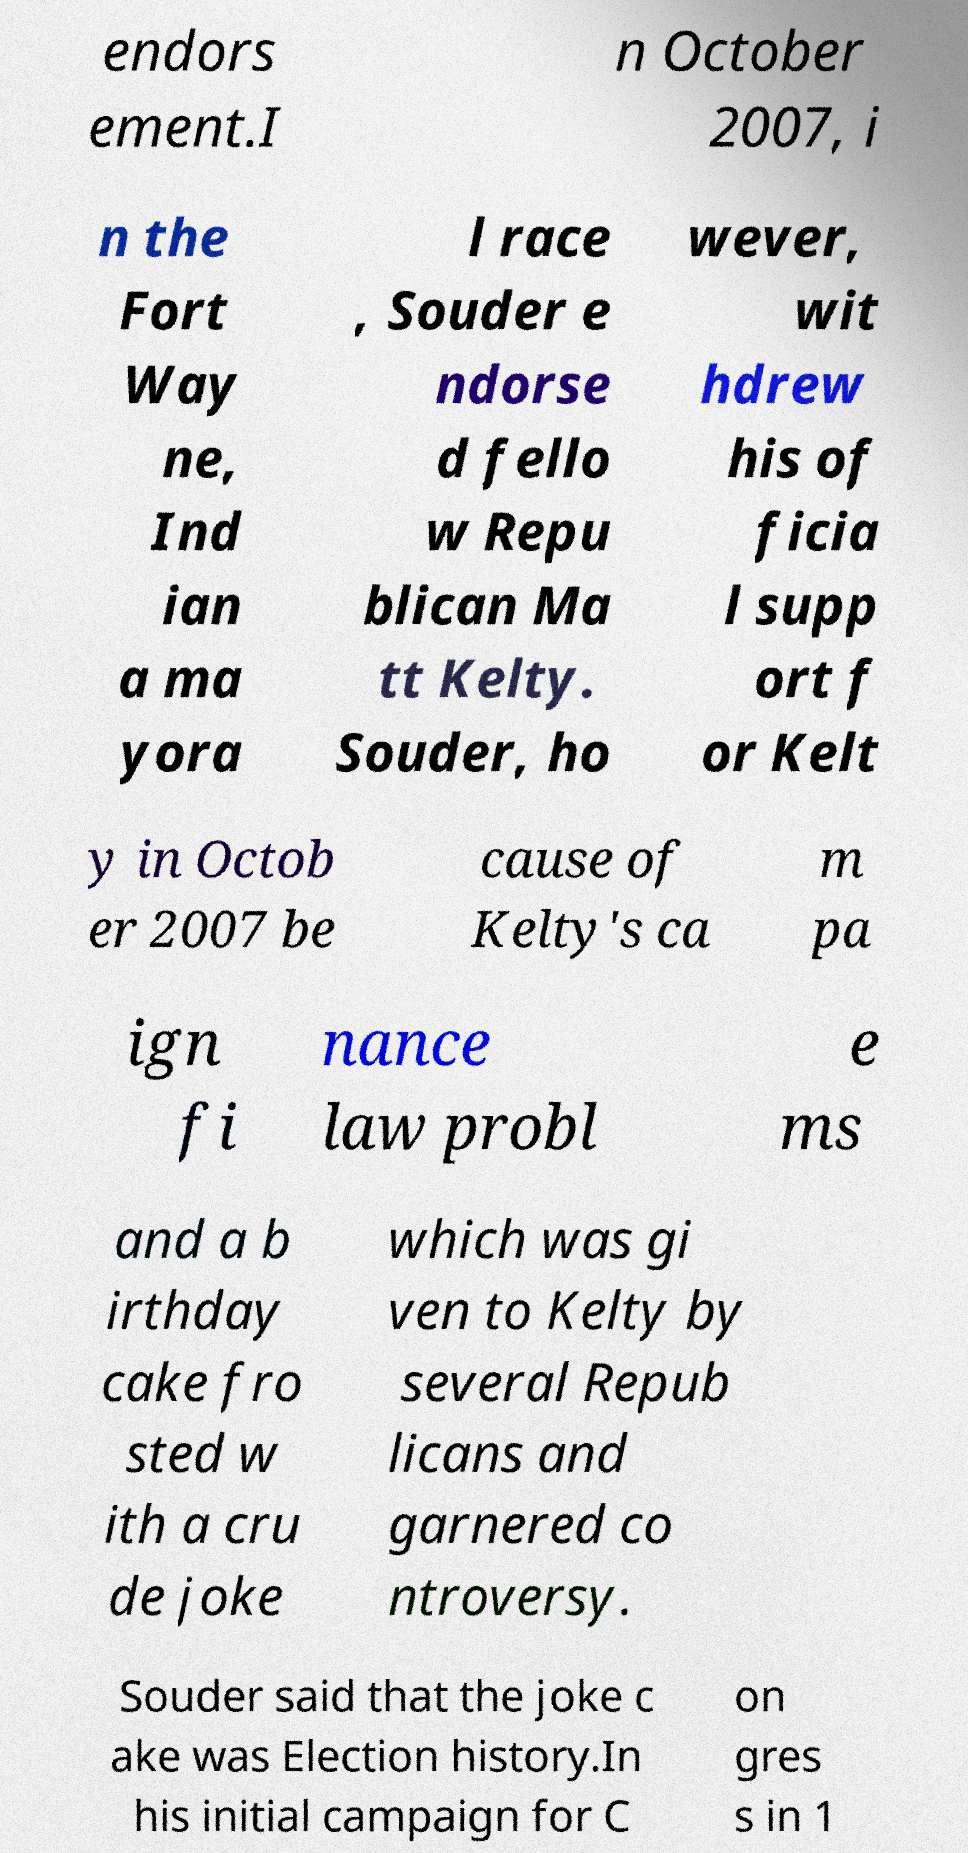Please read and relay the text visible in this image. What does it say? endors ement.I n October 2007, i n the Fort Way ne, Ind ian a ma yora l race , Souder e ndorse d fello w Repu blican Ma tt Kelty. Souder, ho wever, wit hdrew his of ficia l supp ort f or Kelt y in Octob er 2007 be cause of Kelty's ca m pa ign fi nance law probl e ms and a b irthday cake fro sted w ith a cru de joke which was gi ven to Kelty by several Repub licans and garnered co ntroversy. Souder said that the joke c ake was Election history.In his initial campaign for C on gres s in 1 